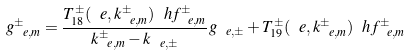Convert formula to latex. <formula><loc_0><loc_0><loc_500><loc_500>g _ { \ e , m } ^ { \pm } = \frac { T _ { 1 8 } ^ { \pm } ( \ e , k _ { \ e , m } ^ { \pm } ) \ h f _ { \ e , m } ^ { \pm } } { k _ { \ e , m } ^ { \pm } - k _ { \ e , \pm } } g _ { \ e , \pm } + T _ { 1 9 } ^ { \pm } ( \ e , k _ { \ e , m } ^ { \pm } ) \ h f _ { \ e , m } ^ { \pm }</formula> 